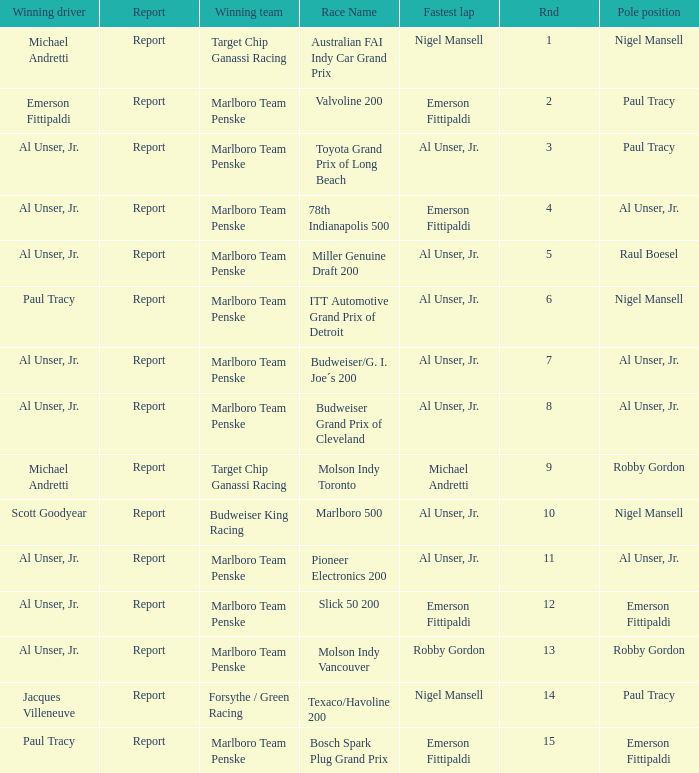What's the report of the race won by Michael Andretti, with Nigel Mansell driving the fastest lap? Report. 